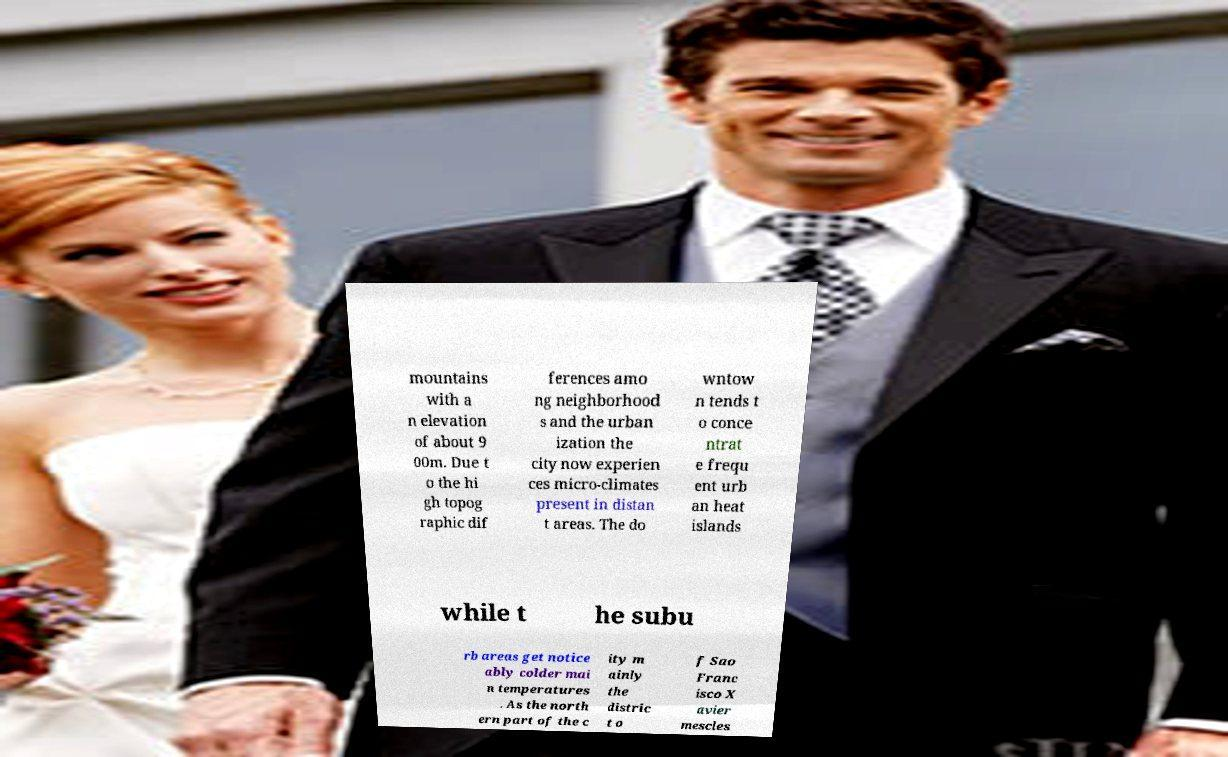For documentation purposes, I need the text within this image transcribed. Could you provide that? mountains with a n elevation of about 9 00m. Due t o the hi gh topog raphic dif ferences amo ng neighborhood s and the urban ization the city now experien ces micro-climates present in distan t areas. The do wntow n tends t o conce ntrat e frequ ent urb an heat islands while t he subu rb areas get notice ably colder mai n temperatures . As the north ern part of the c ity m ainly the distric t o f Sao Franc isco X avier mescles 